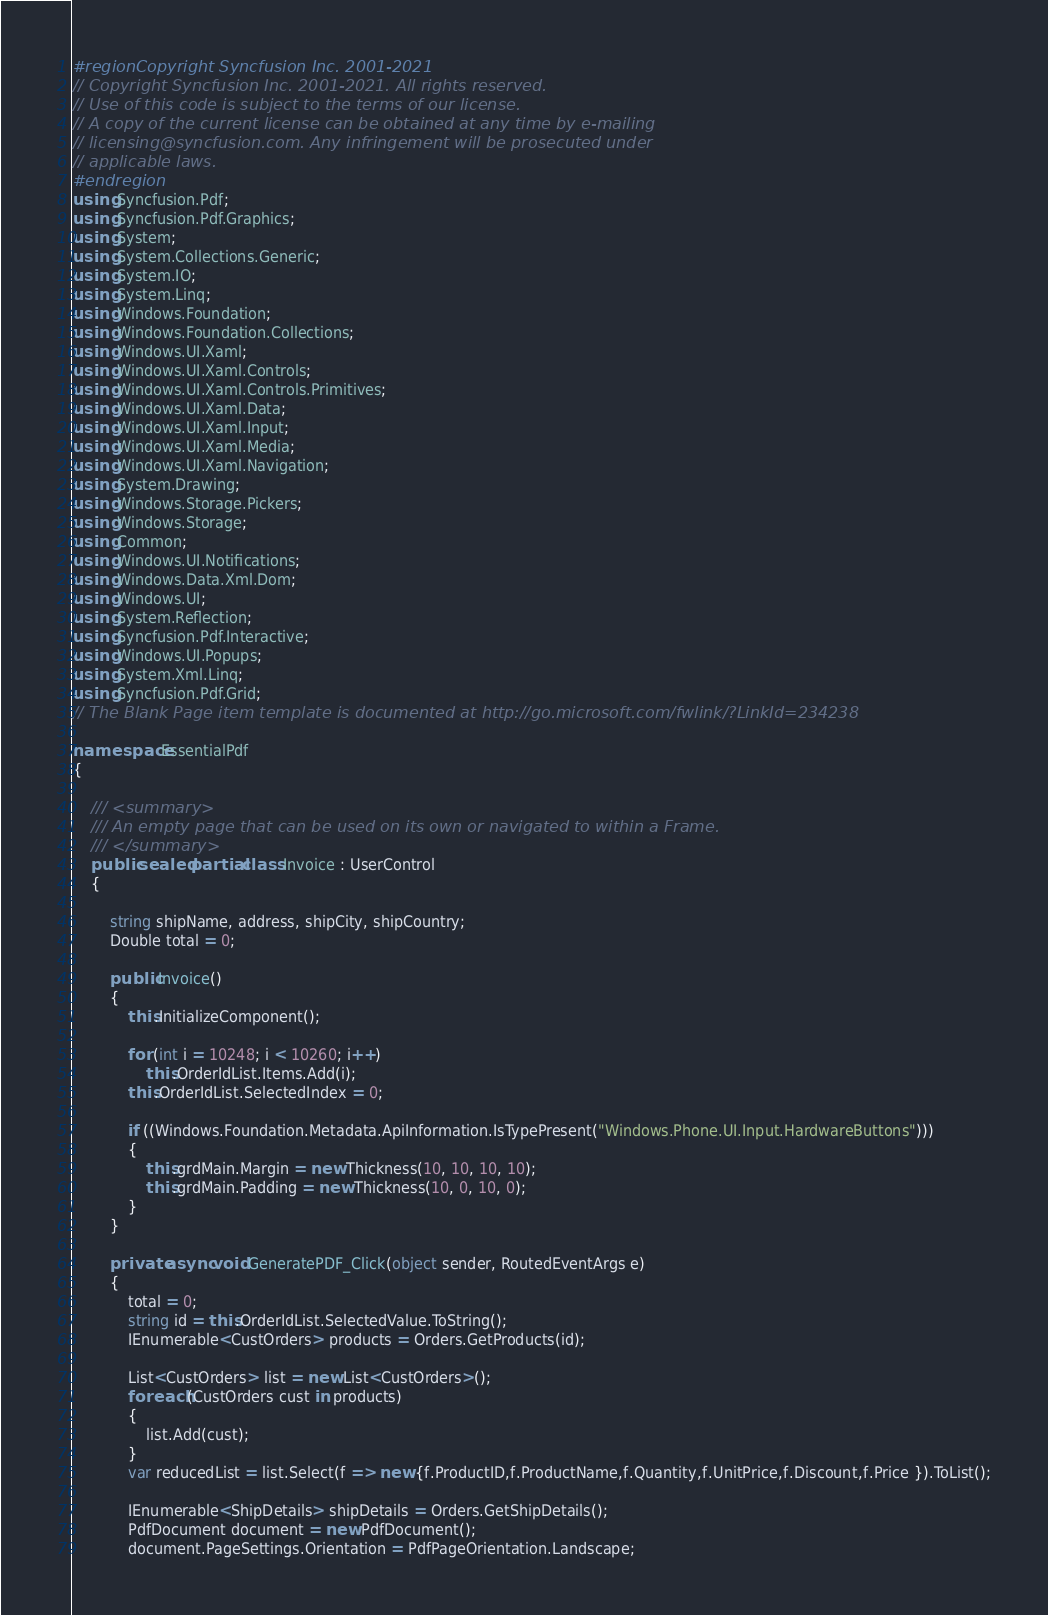Convert code to text. <code><loc_0><loc_0><loc_500><loc_500><_C#_>#region Copyright Syncfusion Inc. 2001-2021
// Copyright Syncfusion Inc. 2001-2021. All rights reserved.
// Use of this code is subject to the terms of our license.
// A copy of the current license can be obtained at any time by e-mailing
// licensing@syncfusion.com. Any infringement will be prosecuted under
// applicable laws. 
#endregion
using Syncfusion.Pdf;
using Syncfusion.Pdf.Graphics;
using System;
using System.Collections.Generic;
using System.IO;
using System.Linq;
using Windows.Foundation;
using Windows.Foundation.Collections;
using Windows.UI.Xaml;
using Windows.UI.Xaml.Controls;
using Windows.UI.Xaml.Controls.Primitives;
using Windows.UI.Xaml.Data;
using Windows.UI.Xaml.Input;
using Windows.UI.Xaml.Media;
using Windows.UI.Xaml.Navigation;
using System.Drawing;
using Windows.Storage.Pickers;
using Windows.Storage;
using Common;
using Windows.UI.Notifications;
using Windows.Data.Xml.Dom;
using Windows.UI;
using System.Reflection;
using Syncfusion.Pdf.Interactive;
using Windows.UI.Popups;
using System.Xml.Linq;
using Syncfusion.Pdf.Grid;
// The Blank Page item template is documented at http://go.microsoft.com/fwlink/?LinkId=234238

namespace EssentialPdf
{ 
  
    /// <summary>
    /// An empty page that can be used on its own or navigated to within a Frame.
    /// </summary>
    public sealed partial class Invoice : UserControl
    {

        string shipName, address, shipCity, shipCountry;
        Double total = 0;   

        public Invoice()
        {
            this.InitializeComponent();
         
            for (int i = 10248; i < 10260; i++)
                this.OrderIdList.Items.Add(i);
            this.OrderIdList.SelectedIndex = 0;

            if ((Windows.Foundation.Metadata.ApiInformation.IsTypePresent("Windows.Phone.UI.Input.HardwareButtons")))
            {
                this.grdMain.Margin = new Thickness(10, 10, 10, 10);
                this.grdMain.Padding = new Thickness(10, 0, 10, 0);
            }
        }      

        private async void GeneratePDF_Click(object sender, RoutedEventArgs e)
        {
            total = 0;
            string id = this.OrderIdList.SelectedValue.ToString();
            IEnumerable<CustOrders> products = Orders.GetProducts(id);

            List<CustOrders> list = new List<CustOrders>();
            foreach (CustOrders cust in products)
            {               
                list.Add(cust);
            }            
            var reducedList = list.Select(f => new {f.ProductID,f.ProductName,f.Quantity,f.UnitPrice,f.Discount,f.Price }).ToList();

            IEnumerable<ShipDetails> shipDetails = Orders.GetShipDetails();
            PdfDocument document = new PdfDocument();
            document.PageSettings.Orientation = PdfPageOrientation.Landscape;</code> 